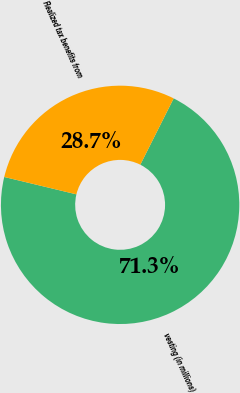Convert chart. <chart><loc_0><loc_0><loc_500><loc_500><pie_chart><fcel>vesting (in millions)<fcel>Realized tax benefits from<nl><fcel>71.34%<fcel>28.66%<nl></chart> 